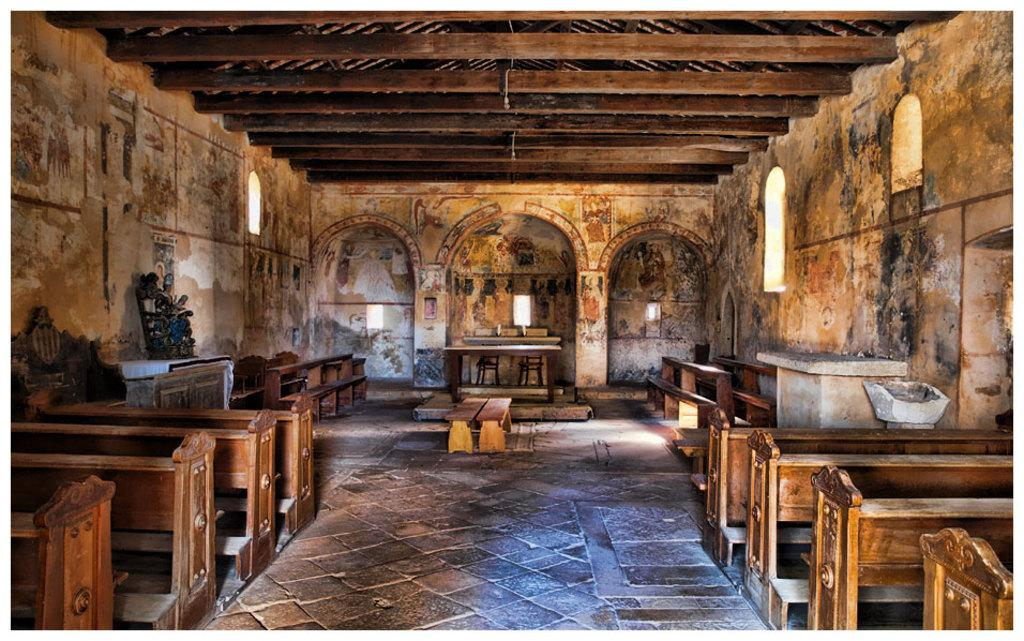What type of space is shown in the image? The image depicts a room. What can be seen hanging from the ceiling in the room? There are brown-colored branches visible in the room. What other furniture can be seen in the background of the room? There are additional benches visible in the background. What type of storage is available in the room? There are shelves present in the room. How many tickets are visible on the shelves in the image? There are no tickets visible on the shelves in the image. What suggestions can be made based on the image? The image does not provide any specific suggestions; it simply shows a room with brown-colored branches, benches, and shelves. 